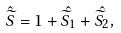Convert formula to latex. <formula><loc_0><loc_0><loc_500><loc_500>\hat { \widetilde { S } } = 1 + \hat { \widetilde { S } _ { 1 } } + \hat { \widetilde { S } _ { 2 } } ,</formula> 